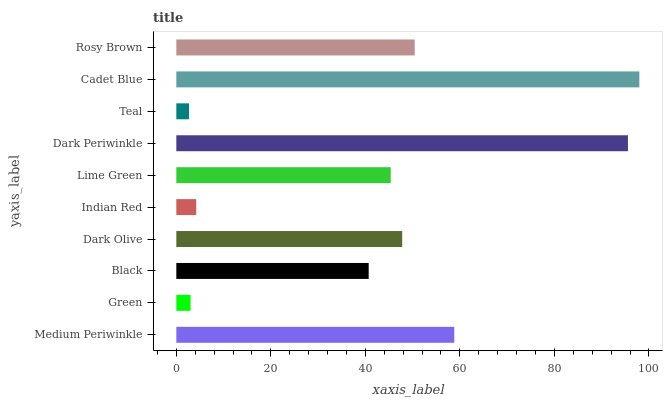Is Teal the minimum?
Answer yes or no. Yes. Is Cadet Blue the maximum?
Answer yes or no. Yes. Is Green the minimum?
Answer yes or no. No. Is Green the maximum?
Answer yes or no. No. Is Medium Periwinkle greater than Green?
Answer yes or no. Yes. Is Green less than Medium Periwinkle?
Answer yes or no. Yes. Is Green greater than Medium Periwinkle?
Answer yes or no. No. Is Medium Periwinkle less than Green?
Answer yes or no. No. Is Dark Olive the high median?
Answer yes or no. Yes. Is Lime Green the low median?
Answer yes or no. Yes. Is Teal the high median?
Answer yes or no. No. Is Dark Olive the low median?
Answer yes or no. No. 